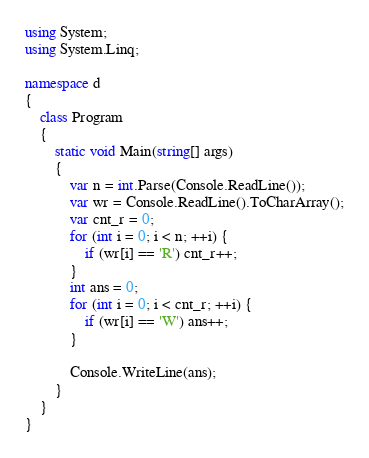<code> <loc_0><loc_0><loc_500><loc_500><_C#_>using System;
using System.Linq;

namespace d
{
    class Program
    {
        static void Main(string[] args)
        {
            var n = int.Parse(Console.ReadLine());
            var wr = Console.ReadLine().ToCharArray();
            var cnt_r = 0;
            for (int i = 0; i < n; ++i) {
                if (wr[i] == 'R') cnt_r++;
            }
            int ans = 0;
            for (int i = 0; i < cnt_r; ++i) {
                if (wr[i] == 'W') ans++;
            }

            Console.WriteLine(ans);
        }
    }
}
</code> 